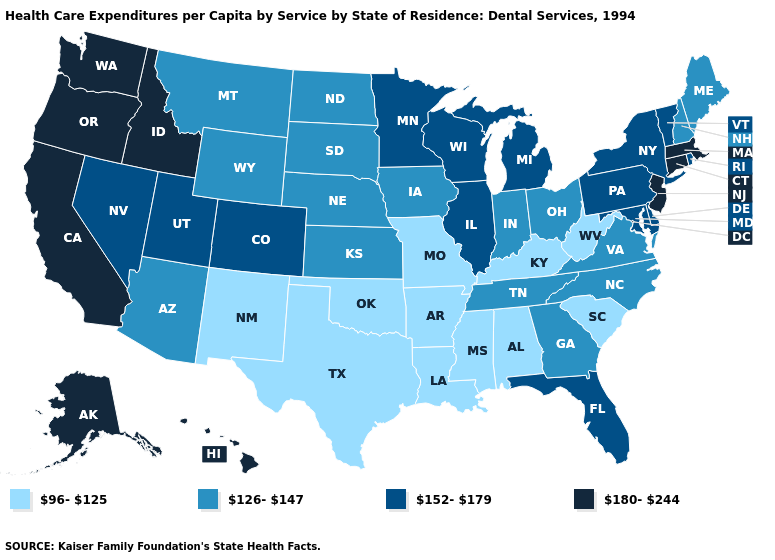Does Nebraska have a lower value than Maryland?
Give a very brief answer. Yes. Among the states that border Idaho , which have the lowest value?
Give a very brief answer. Montana, Wyoming. Does South Carolina have the highest value in the USA?
Write a very short answer. No. Name the states that have a value in the range 152-179?
Short answer required. Colorado, Delaware, Florida, Illinois, Maryland, Michigan, Minnesota, Nevada, New York, Pennsylvania, Rhode Island, Utah, Vermont, Wisconsin. Is the legend a continuous bar?
Write a very short answer. No. What is the highest value in the Northeast ?
Quick response, please. 180-244. What is the highest value in states that border Ohio?
Short answer required. 152-179. Does Missouri have the lowest value in the USA?
Quick response, please. Yes. Does Alaska have the highest value in the USA?
Give a very brief answer. Yes. What is the lowest value in the USA?
Write a very short answer. 96-125. Name the states that have a value in the range 126-147?
Keep it brief. Arizona, Georgia, Indiana, Iowa, Kansas, Maine, Montana, Nebraska, New Hampshire, North Carolina, North Dakota, Ohio, South Dakota, Tennessee, Virginia, Wyoming. What is the lowest value in the USA?
Write a very short answer. 96-125. Which states have the highest value in the USA?
Quick response, please. Alaska, California, Connecticut, Hawaii, Idaho, Massachusetts, New Jersey, Oregon, Washington. Name the states that have a value in the range 96-125?
Be succinct. Alabama, Arkansas, Kentucky, Louisiana, Mississippi, Missouri, New Mexico, Oklahoma, South Carolina, Texas, West Virginia. 